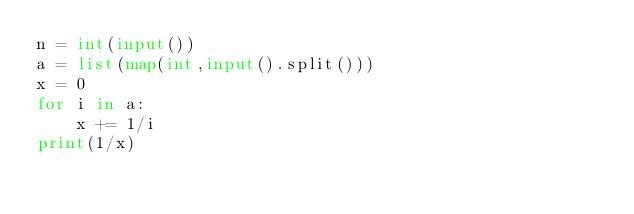Convert code to text. <code><loc_0><loc_0><loc_500><loc_500><_Python_>n = int(input())
a = list(map(int,input().split()))
x = 0
for i in a:
    x += 1/i
print(1/x)</code> 